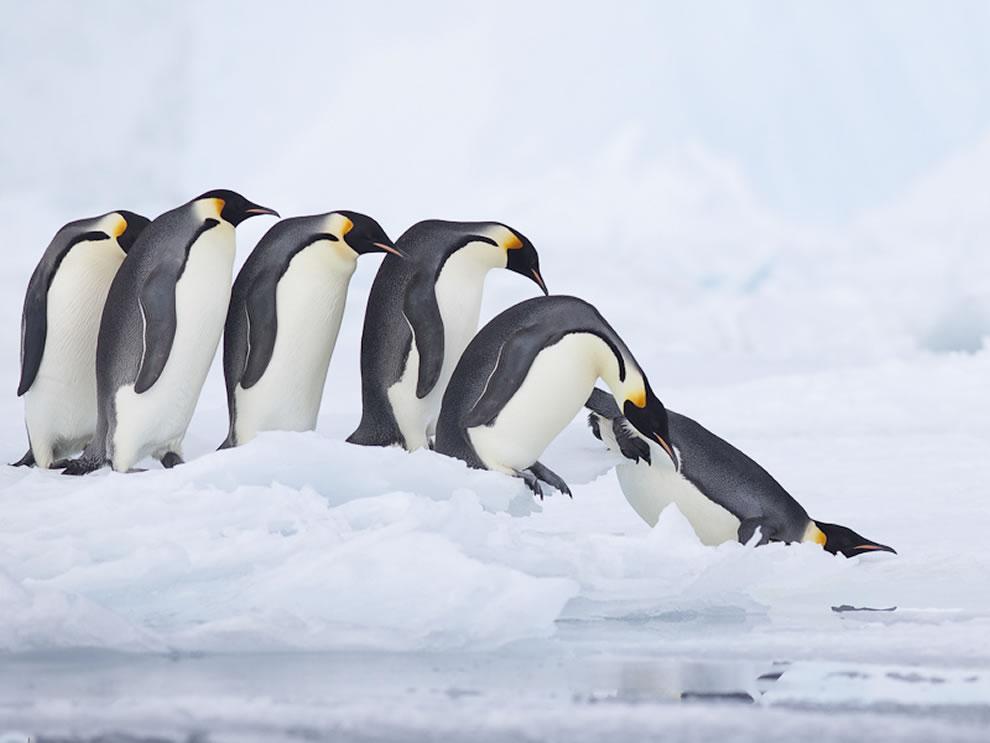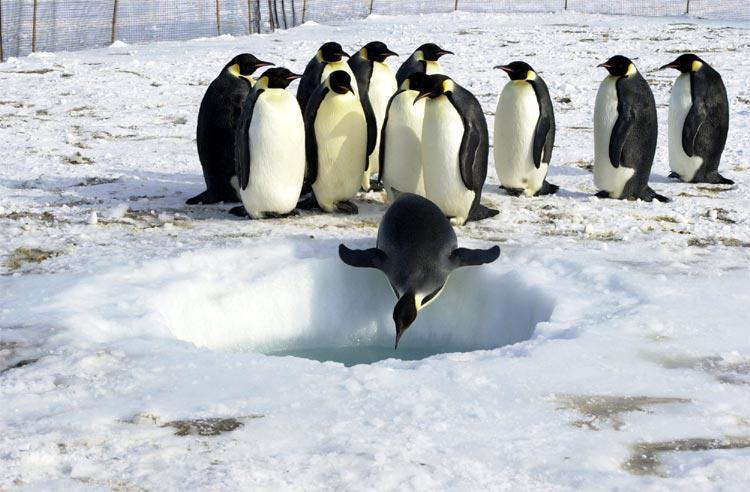The first image is the image on the left, the second image is the image on the right. Given the left and right images, does the statement "One of the images features a penguin who is obviously young - still a chick!" hold true? Answer yes or no. No. The first image is the image on the left, the second image is the image on the right. Analyze the images presented: Is the assertion "The image on the left shows no more than 7 penguins." valid? Answer yes or no. Yes. 